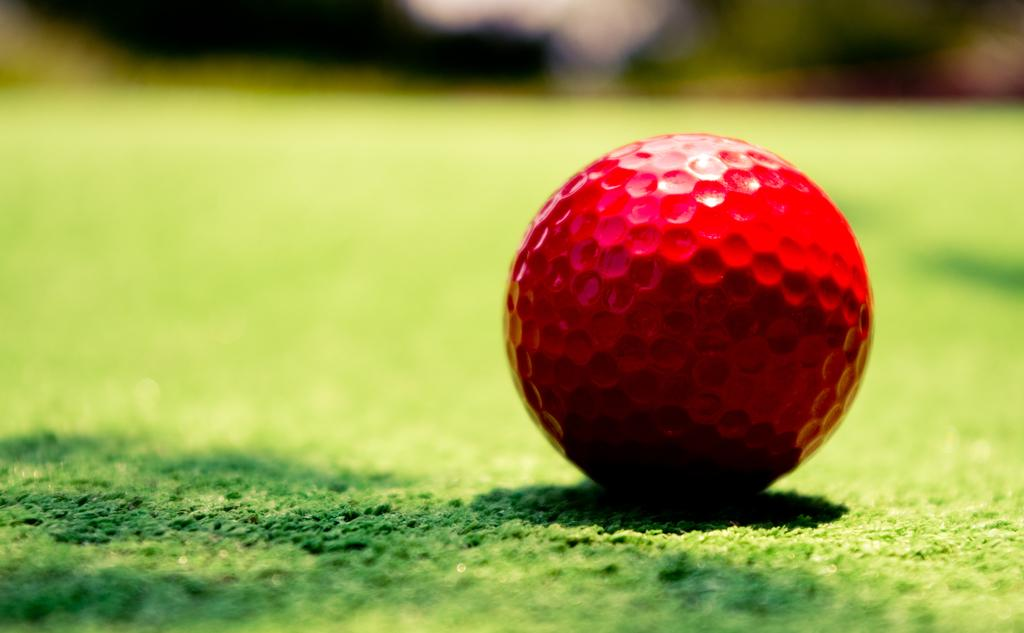What color is the golf ball in the image? The golf ball in the image is red. Where is the golf ball located? The golf ball is on the grassland. How many kittens are playing with the golf ball in the image? There are no kittens present in the image; it only features a red golf ball on the grassland. 